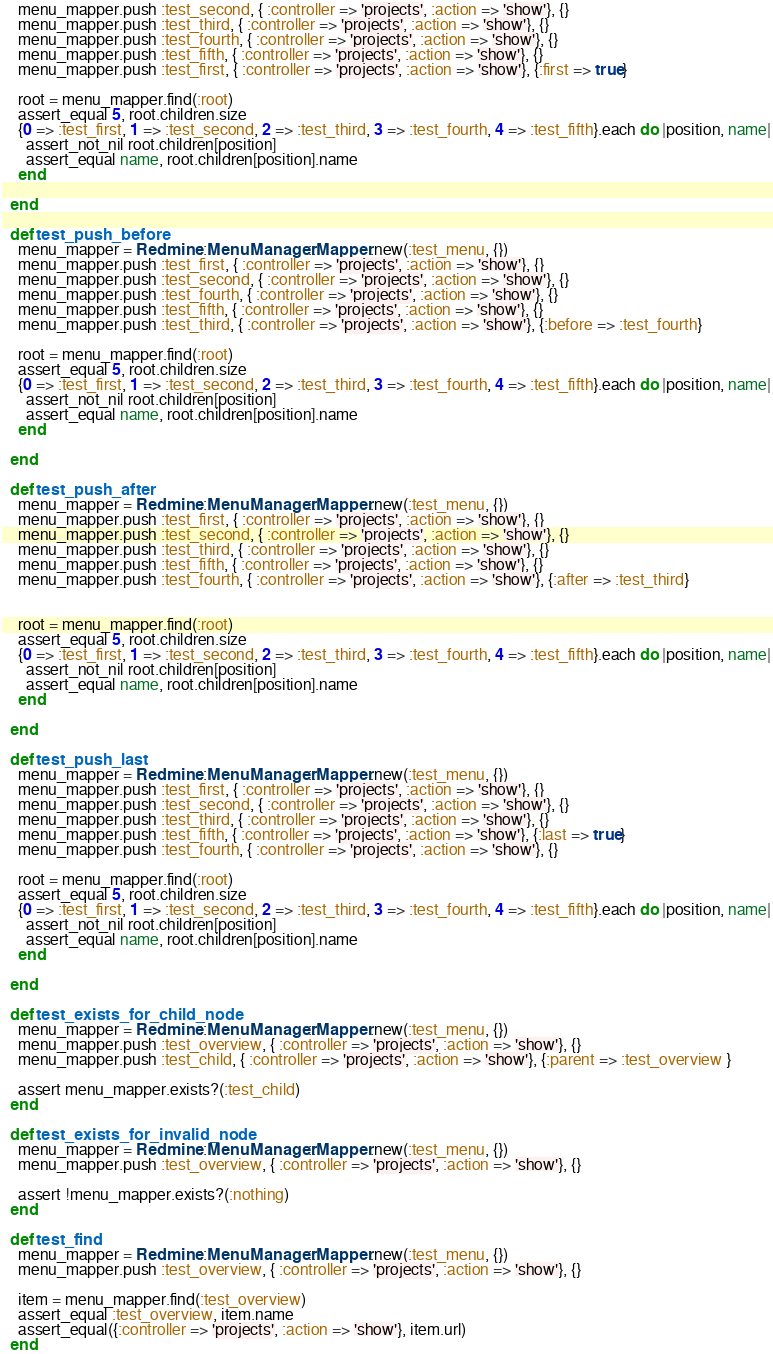<code> <loc_0><loc_0><loc_500><loc_500><_Ruby_>    menu_mapper.push :test_second, { :controller => 'projects', :action => 'show'}, {}
    menu_mapper.push :test_third, { :controller => 'projects', :action => 'show'}, {}
    menu_mapper.push :test_fourth, { :controller => 'projects', :action => 'show'}, {}
    menu_mapper.push :test_fifth, { :controller => 'projects', :action => 'show'}, {}
    menu_mapper.push :test_first, { :controller => 'projects', :action => 'show'}, {:first => true}

    root = menu_mapper.find(:root)
    assert_equal 5, root.children.size
    {0 => :test_first, 1 => :test_second, 2 => :test_third, 3 => :test_fourth, 4 => :test_fifth}.each do |position, name|
      assert_not_nil root.children[position]
      assert_equal name, root.children[position].name
    end

  end

  def test_push_before
    menu_mapper = Redmine::MenuManager::Mapper.new(:test_menu, {})
    menu_mapper.push :test_first, { :controller => 'projects', :action => 'show'}, {}
    menu_mapper.push :test_second, { :controller => 'projects', :action => 'show'}, {}
    menu_mapper.push :test_fourth, { :controller => 'projects', :action => 'show'}, {}
    menu_mapper.push :test_fifth, { :controller => 'projects', :action => 'show'}, {}
    menu_mapper.push :test_third, { :controller => 'projects', :action => 'show'}, {:before => :test_fourth}

    root = menu_mapper.find(:root)
    assert_equal 5, root.children.size
    {0 => :test_first, 1 => :test_second, 2 => :test_third, 3 => :test_fourth, 4 => :test_fifth}.each do |position, name|
      assert_not_nil root.children[position]
      assert_equal name, root.children[position].name
    end

  end

  def test_push_after
    menu_mapper = Redmine::MenuManager::Mapper.new(:test_menu, {})
    menu_mapper.push :test_first, { :controller => 'projects', :action => 'show'}, {}
    menu_mapper.push :test_second, { :controller => 'projects', :action => 'show'}, {}
    menu_mapper.push :test_third, { :controller => 'projects', :action => 'show'}, {}
    menu_mapper.push :test_fifth, { :controller => 'projects', :action => 'show'}, {}
    menu_mapper.push :test_fourth, { :controller => 'projects', :action => 'show'}, {:after => :test_third}


    root = menu_mapper.find(:root)
    assert_equal 5, root.children.size
    {0 => :test_first, 1 => :test_second, 2 => :test_third, 3 => :test_fourth, 4 => :test_fifth}.each do |position, name|
      assert_not_nil root.children[position]
      assert_equal name, root.children[position].name
    end

  end

  def test_push_last
    menu_mapper = Redmine::MenuManager::Mapper.new(:test_menu, {})
    menu_mapper.push :test_first, { :controller => 'projects', :action => 'show'}, {}
    menu_mapper.push :test_second, { :controller => 'projects', :action => 'show'}, {}
    menu_mapper.push :test_third, { :controller => 'projects', :action => 'show'}, {}
    menu_mapper.push :test_fifth, { :controller => 'projects', :action => 'show'}, {:last => true}
    menu_mapper.push :test_fourth, { :controller => 'projects', :action => 'show'}, {}

    root = menu_mapper.find(:root)
    assert_equal 5, root.children.size
    {0 => :test_first, 1 => :test_second, 2 => :test_third, 3 => :test_fourth, 4 => :test_fifth}.each do |position, name|
      assert_not_nil root.children[position]
      assert_equal name, root.children[position].name
    end

  end

  def test_exists_for_child_node
    menu_mapper = Redmine::MenuManager::Mapper.new(:test_menu, {})
    menu_mapper.push :test_overview, { :controller => 'projects', :action => 'show'}, {}
    menu_mapper.push :test_child, { :controller => 'projects', :action => 'show'}, {:parent => :test_overview }

    assert menu_mapper.exists?(:test_child)
  end

  def test_exists_for_invalid_node
    menu_mapper = Redmine::MenuManager::Mapper.new(:test_menu, {})
    menu_mapper.push :test_overview, { :controller => 'projects', :action => 'show'}, {}

    assert !menu_mapper.exists?(:nothing)
  end

  def test_find
    menu_mapper = Redmine::MenuManager::Mapper.new(:test_menu, {})
    menu_mapper.push :test_overview, { :controller => 'projects', :action => 'show'}, {}

    item = menu_mapper.find(:test_overview)
    assert_equal :test_overview, item.name
    assert_equal({:controller => 'projects', :action => 'show'}, item.url)
  end
</code> 